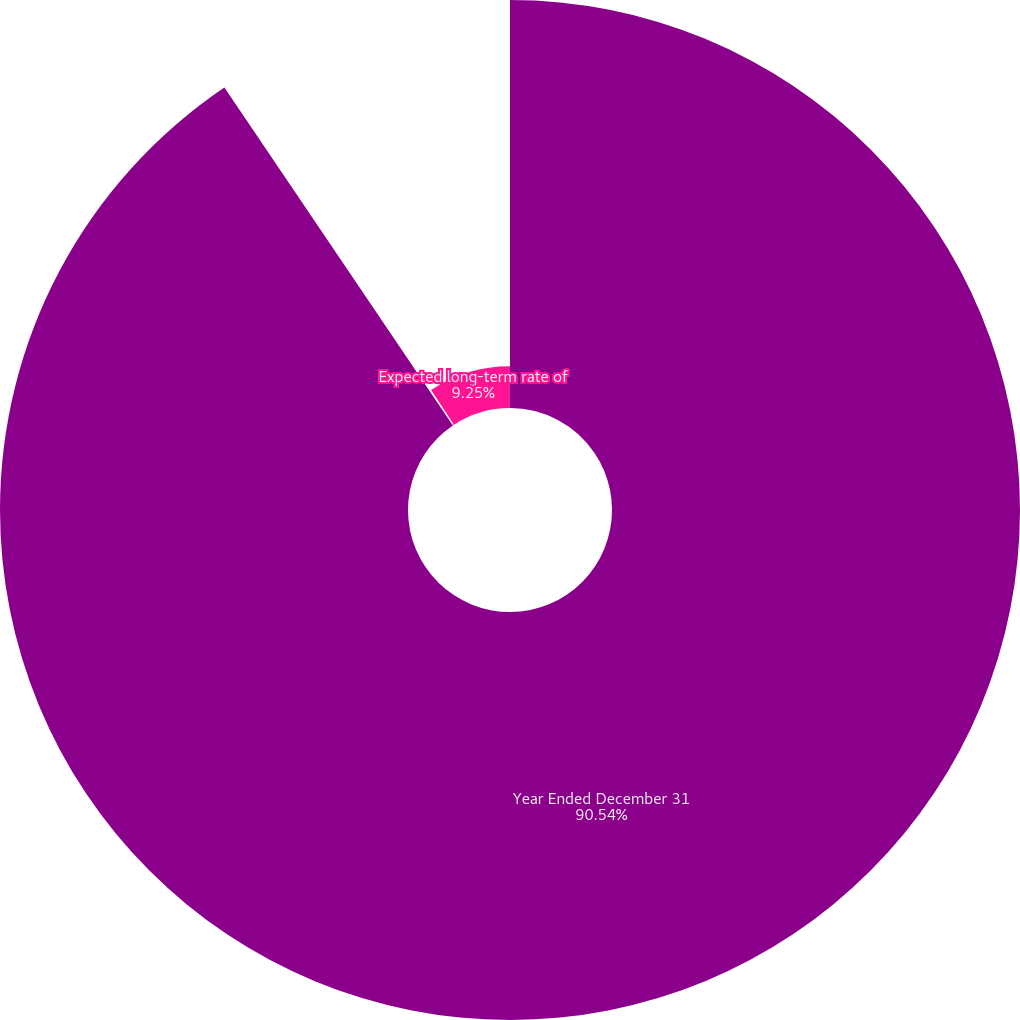Convert chart. <chart><loc_0><loc_0><loc_500><loc_500><pie_chart><fcel>Year Ended December 31<fcel>Discount rate<fcel>Expected long-term rate of<nl><fcel>90.54%<fcel>0.21%<fcel>9.25%<nl></chart> 